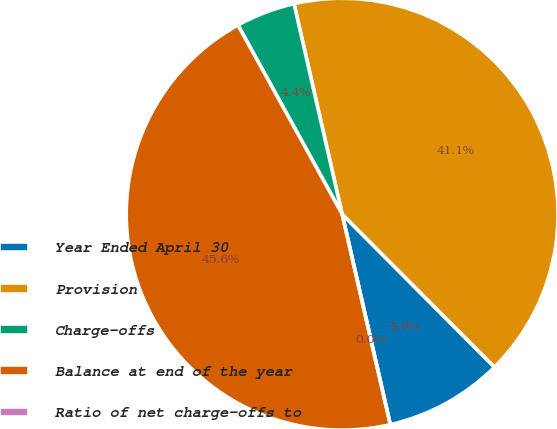<chart> <loc_0><loc_0><loc_500><loc_500><pie_chart><fcel>Year Ended April 30<fcel>Provision<fcel>Charge-offs<fcel>Balance at end of the year<fcel>Ratio of net charge-offs to<nl><fcel>8.89%<fcel>41.11%<fcel>4.44%<fcel>45.56%<fcel>0.0%<nl></chart> 